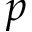<formula> <loc_0><loc_0><loc_500><loc_500>p</formula> 